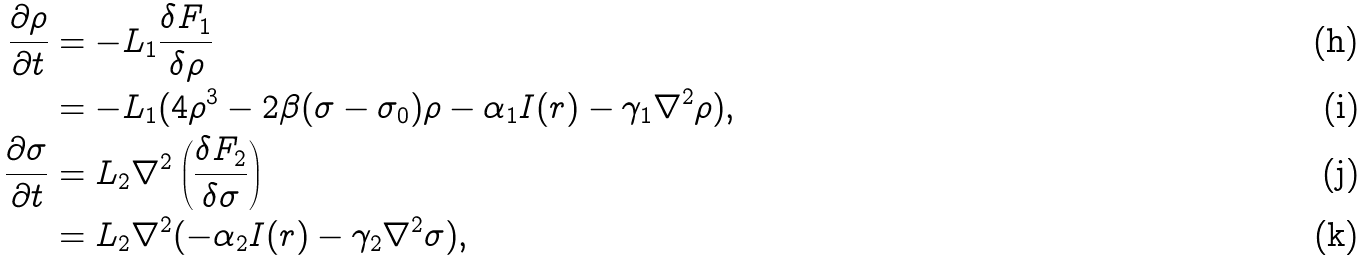<formula> <loc_0><loc_0><loc_500><loc_500>\frac { \partial \rho } { \partial t } & = - L _ { 1 } \frac { \delta F _ { 1 } } { \delta \rho } \\ & = - L _ { 1 } ( 4 \rho ^ { 3 } - 2 \beta ( \sigma - \sigma _ { 0 } ) \rho - \alpha _ { 1 } I ( r ) - \gamma _ { 1 } \nabla ^ { 2 } \rho ) , \\ \frac { \partial \sigma } { \partial t } & = L _ { 2 } \nabla ^ { 2 } \left ( \frac { \delta F _ { 2 } } { \delta \sigma } \right ) \\ & = L _ { 2 } \nabla ^ { 2 } ( - \alpha _ { 2 } I ( r ) - \gamma _ { 2 } \nabla ^ { 2 } \sigma ) ,</formula> 